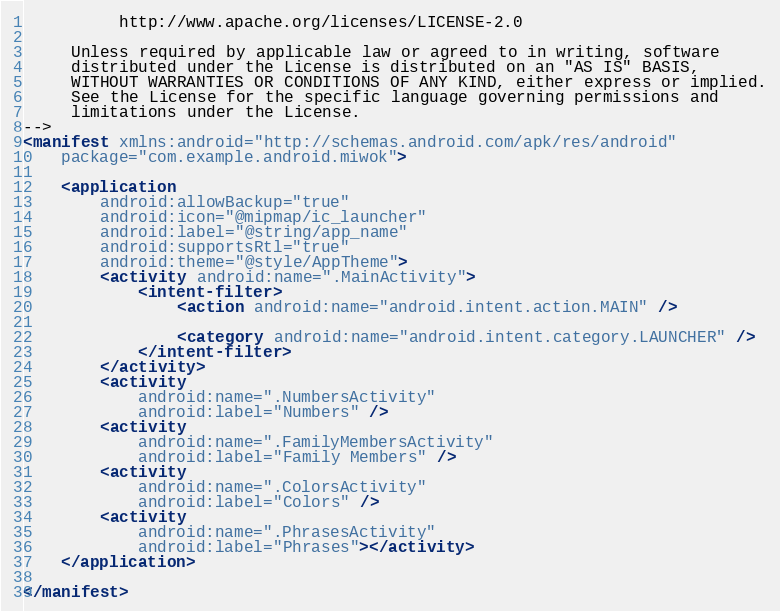<code> <loc_0><loc_0><loc_500><loc_500><_XML_>          http://www.apache.org/licenses/LICENSE-2.0

     Unless required by applicable law or agreed to in writing, software
     distributed under the License is distributed on an "AS IS" BASIS,
     WITHOUT WARRANTIES OR CONDITIONS OF ANY KIND, either express or implied.
     See the License for the specific language governing permissions and
     limitations under the License.
-->
<manifest xmlns:android="http://schemas.android.com/apk/res/android"
    package="com.example.android.miwok">

    <application
        android:allowBackup="true"
        android:icon="@mipmap/ic_launcher"
        android:label="@string/app_name"
        android:supportsRtl="true"
        android:theme="@style/AppTheme">
        <activity android:name=".MainActivity">
            <intent-filter>
                <action android:name="android.intent.action.MAIN" />

                <category android:name="android.intent.category.LAUNCHER" />
            </intent-filter>
        </activity>
        <activity
            android:name=".NumbersActivity"
            android:label="Numbers" />
        <activity
            android:name=".FamilyMembersActivity"
            android:label="Family Members" />
        <activity
            android:name=".ColorsActivity"
            android:label="Colors" />
        <activity
            android:name=".PhrasesActivity"
            android:label="Phrases"></activity>
    </application>

</manifest></code> 